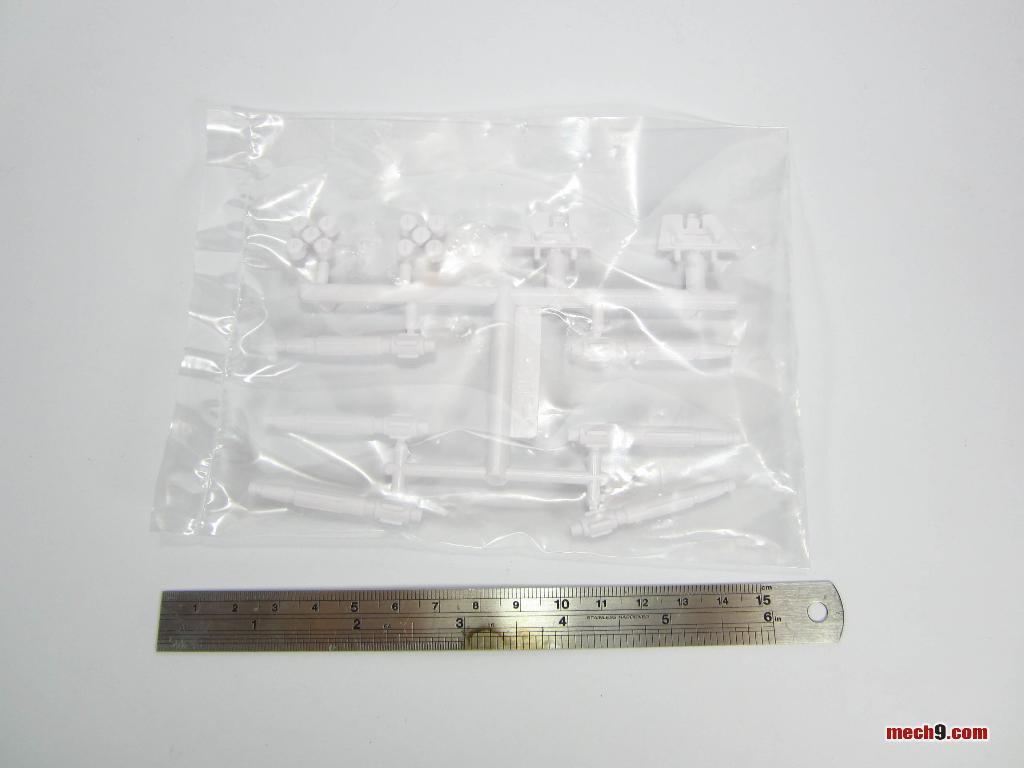<image>
Write a terse but informative summary of the picture. A metal ruler is next to a bag of white plastic parts and says mech9.com. 